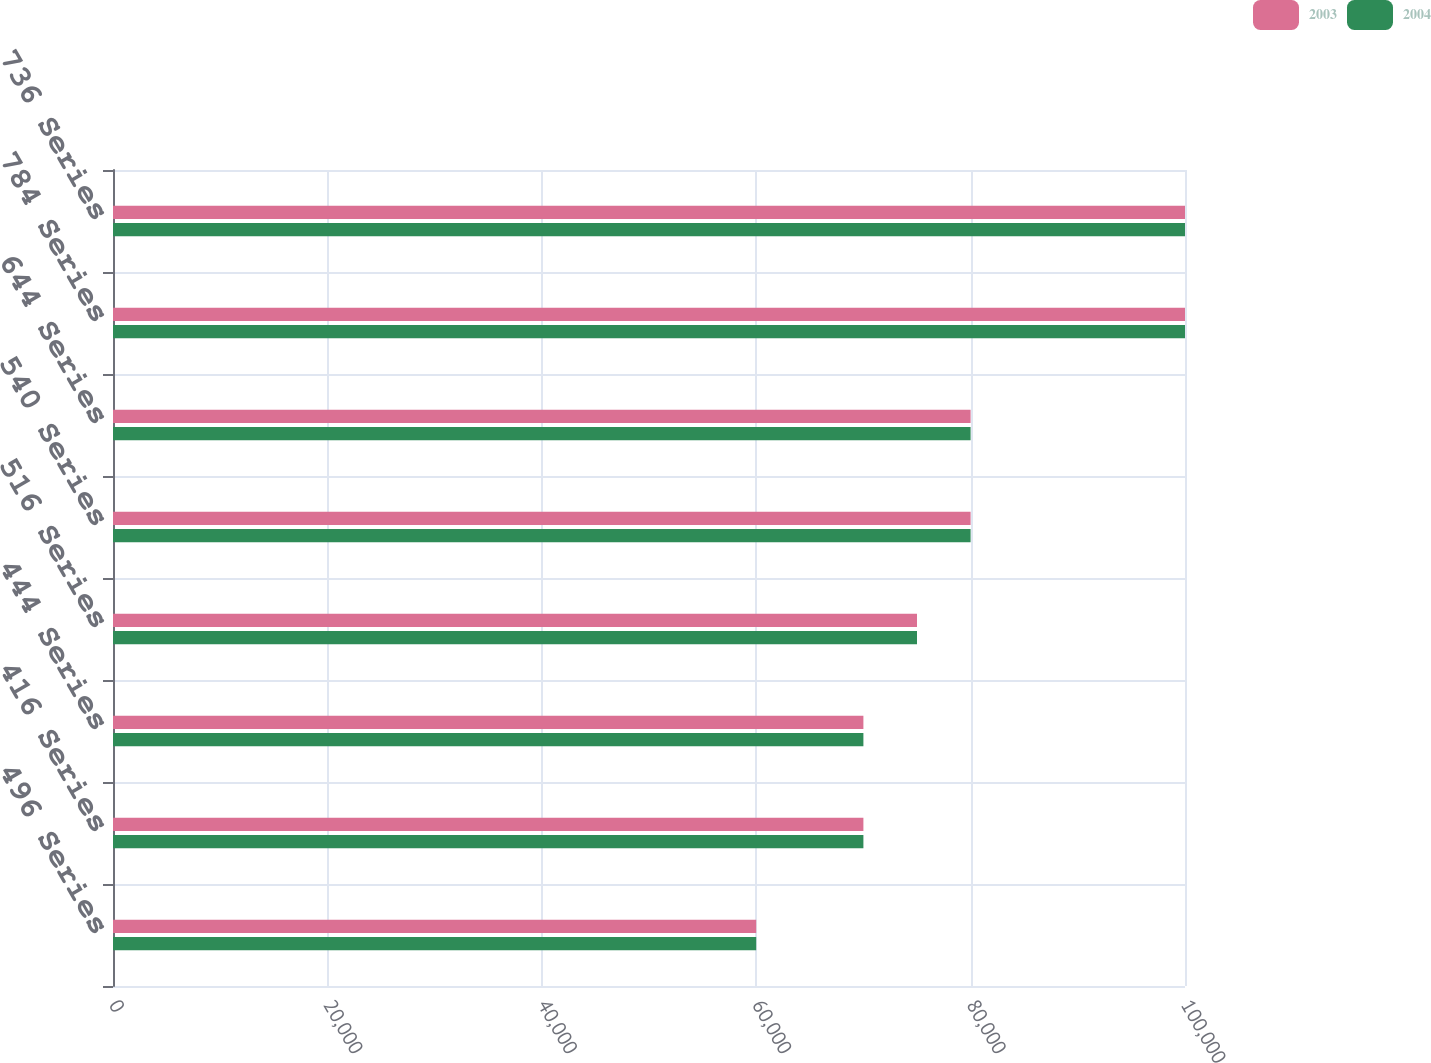<chart> <loc_0><loc_0><loc_500><loc_500><stacked_bar_chart><ecel><fcel>496 Series<fcel>416 Series<fcel>444 Series<fcel>516 Series<fcel>540 Series<fcel>644 Series<fcel>784 Series<fcel>736 Series<nl><fcel>2003<fcel>60000<fcel>70000<fcel>70000<fcel>75000<fcel>80000<fcel>80000<fcel>100000<fcel>100000<nl><fcel>2004<fcel>60000<fcel>70000<fcel>70000<fcel>75000<fcel>80000<fcel>80000<fcel>100000<fcel>100000<nl></chart> 